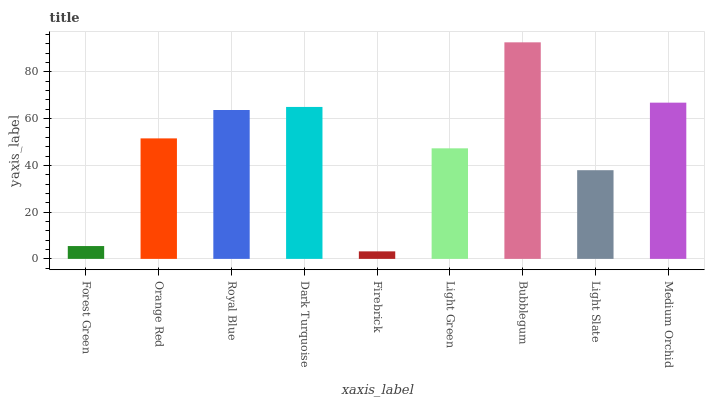Is Firebrick the minimum?
Answer yes or no. Yes. Is Bubblegum the maximum?
Answer yes or no. Yes. Is Orange Red the minimum?
Answer yes or no. No. Is Orange Red the maximum?
Answer yes or no. No. Is Orange Red greater than Forest Green?
Answer yes or no. Yes. Is Forest Green less than Orange Red?
Answer yes or no. Yes. Is Forest Green greater than Orange Red?
Answer yes or no. No. Is Orange Red less than Forest Green?
Answer yes or no. No. Is Orange Red the high median?
Answer yes or no. Yes. Is Orange Red the low median?
Answer yes or no. Yes. Is Forest Green the high median?
Answer yes or no. No. Is Bubblegum the low median?
Answer yes or no. No. 